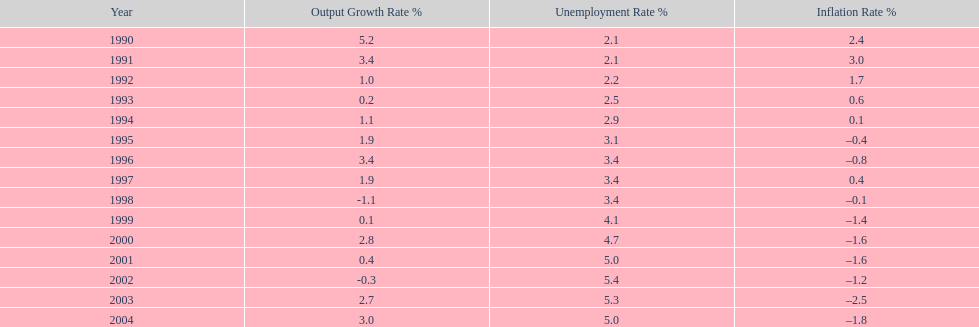In which year was the unemployment rate at its peak? 2002. 